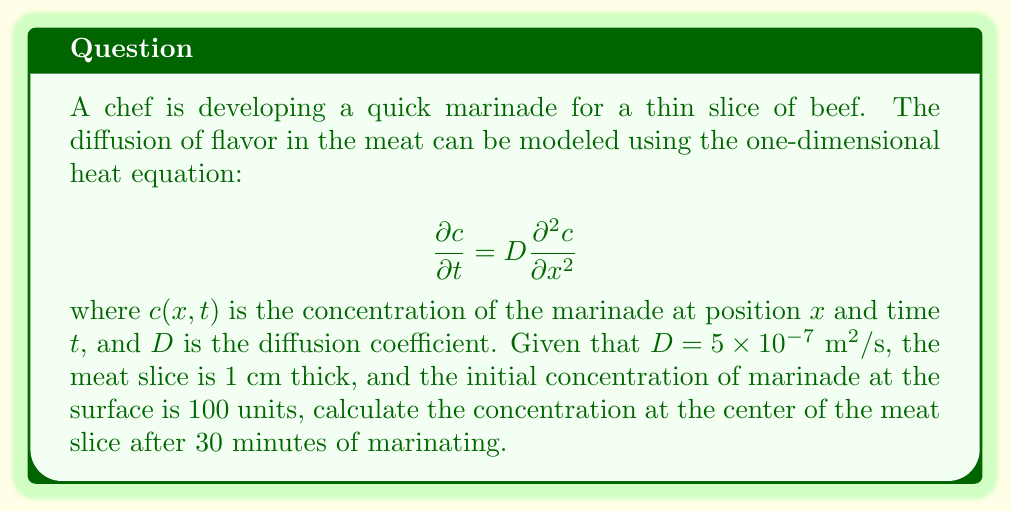Could you help me with this problem? To solve this problem, we'll use the solution to the one-dimensional diffusion equation for a finite slab:

1) The solution for this scenario is given by:

   $$c(x,t) = c_0 \left[1 - \frac{4}{\pi} \sum_{n=0}^{\infty} \frac{(-1)^n}{2n+1} \exp\left(-D(2n+1)^2\pi^2t/L^2\right) \cos\left(\frac{(2n+1)\pi x}{L}\right)\right]$$

   where $c_0$ is the initial surface concentration, $L$ is the thickness of the meat slice.

2) We're interested in the concentration at the center, so $x = L/2 = 0.005 \text{ m}$.

3) Let's substitute the given values:
   $c_0 = 100$
   $D = 5 \times 10^{-7} \text{ m}^2/\text{s}$
   $t = 30 \text{ minutes} = 1800 \text{ s}$
   $L = 0.01 \text{ m}$

4) For practical purposes, we'll sum the first few terms of the series (n = 0 to 4):

   $$c(0.005,1800) = 100 \left[1 - \frac{4}{\pi} \sum_{n=0}^{4} \frac{(-1)^n}{2n+1} \exp\left(-5 \times 10^{-7}(2n+1)^2\pi^2 \times 1800/(0.01)^2\right) \cos\left(\frac{(2n+1)\pi \times 0.005}{0.01}\right)\right]$$

5) Calculating each term:
   n = 0: 0.3679
   n = 1: -0.0442
   n = 2: 0.0027
   n = 3: -0.0001
   n = 4: 0.0000

6) Summing these terms: 0.3263

7) Therefore, the concentration at the center is:
   
   $$c(0.005,1800) = 100 \times (1 - 0.3263) = 67.37$$
Answer: 67.37 units 